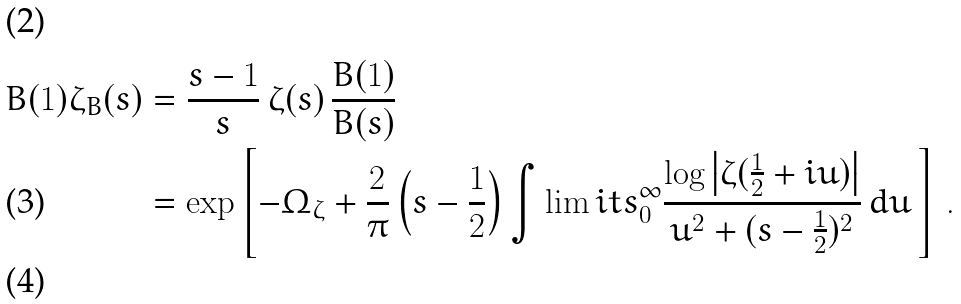Convert formula to latex. <formula><loc_0><loc_0><loc_500><loc_500>B ( 1 ) \zeta _ { B } ( s ) & = \frac { s - 1 } { s } \, \zeta ( s ) \, \frac { B ( 1 ) } { B ( s ) } \\ & = \exp \left [ - \Omega _ { \zeta } + \frac { 2 } { \pi } \left ( s - \frac { 1 } { 2 } \right ) \int \lim i t s _ { 0 } ^ { \infty } \frac { \log \left | \zeta ( \frac { 1 } { 2 } + i u ) \right | } { u ^ { 2 } + ( s - \frac { 1 } { 2 } ) ^ { 2 } } \, d u \, \right ] \, . \\</formula> 